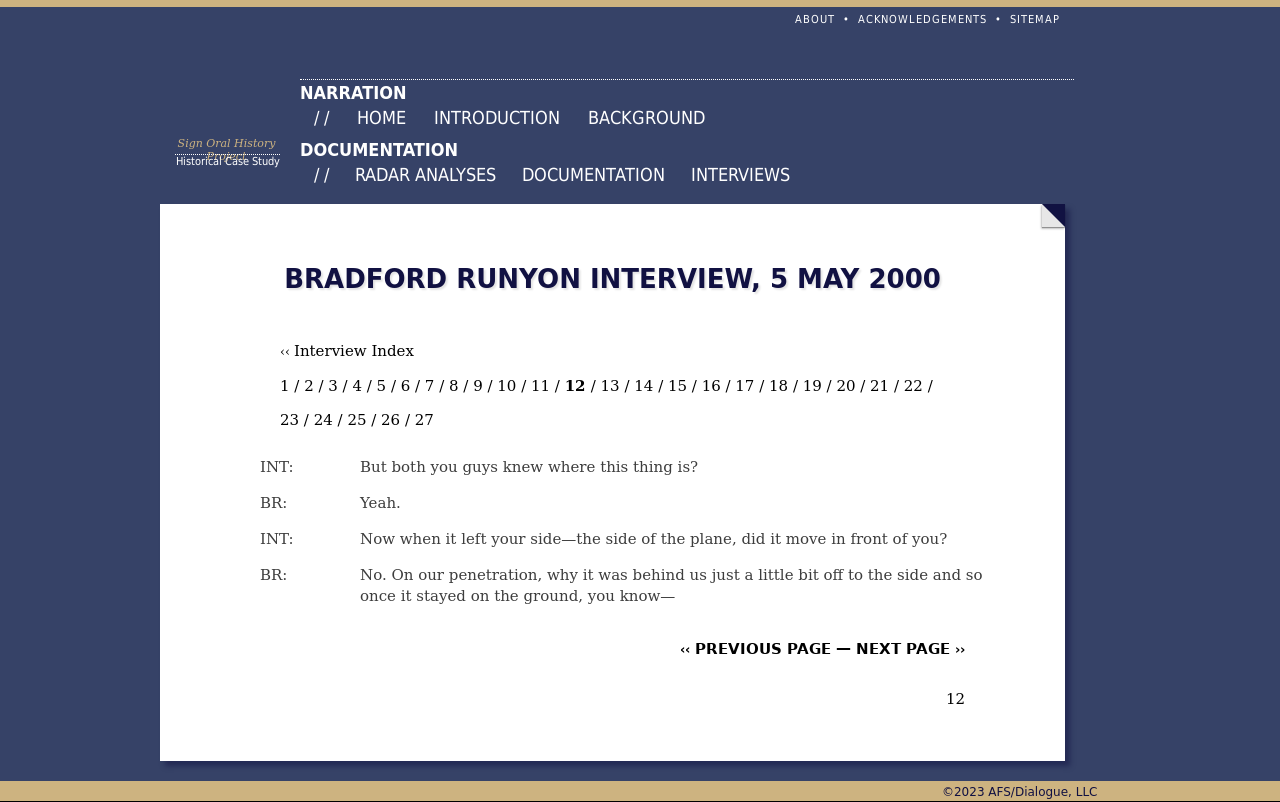Can you describe the theme and content of the webpage shown in the image? The webpage in the image appears to be dedicated to an interview or case study, likely related to an historical event or specific incident given the structured format with date and interviewer initials. The navigation bar suggests the content includes sections such as background information, documentation, and interviews, indicating thorough exploration of the topic. 